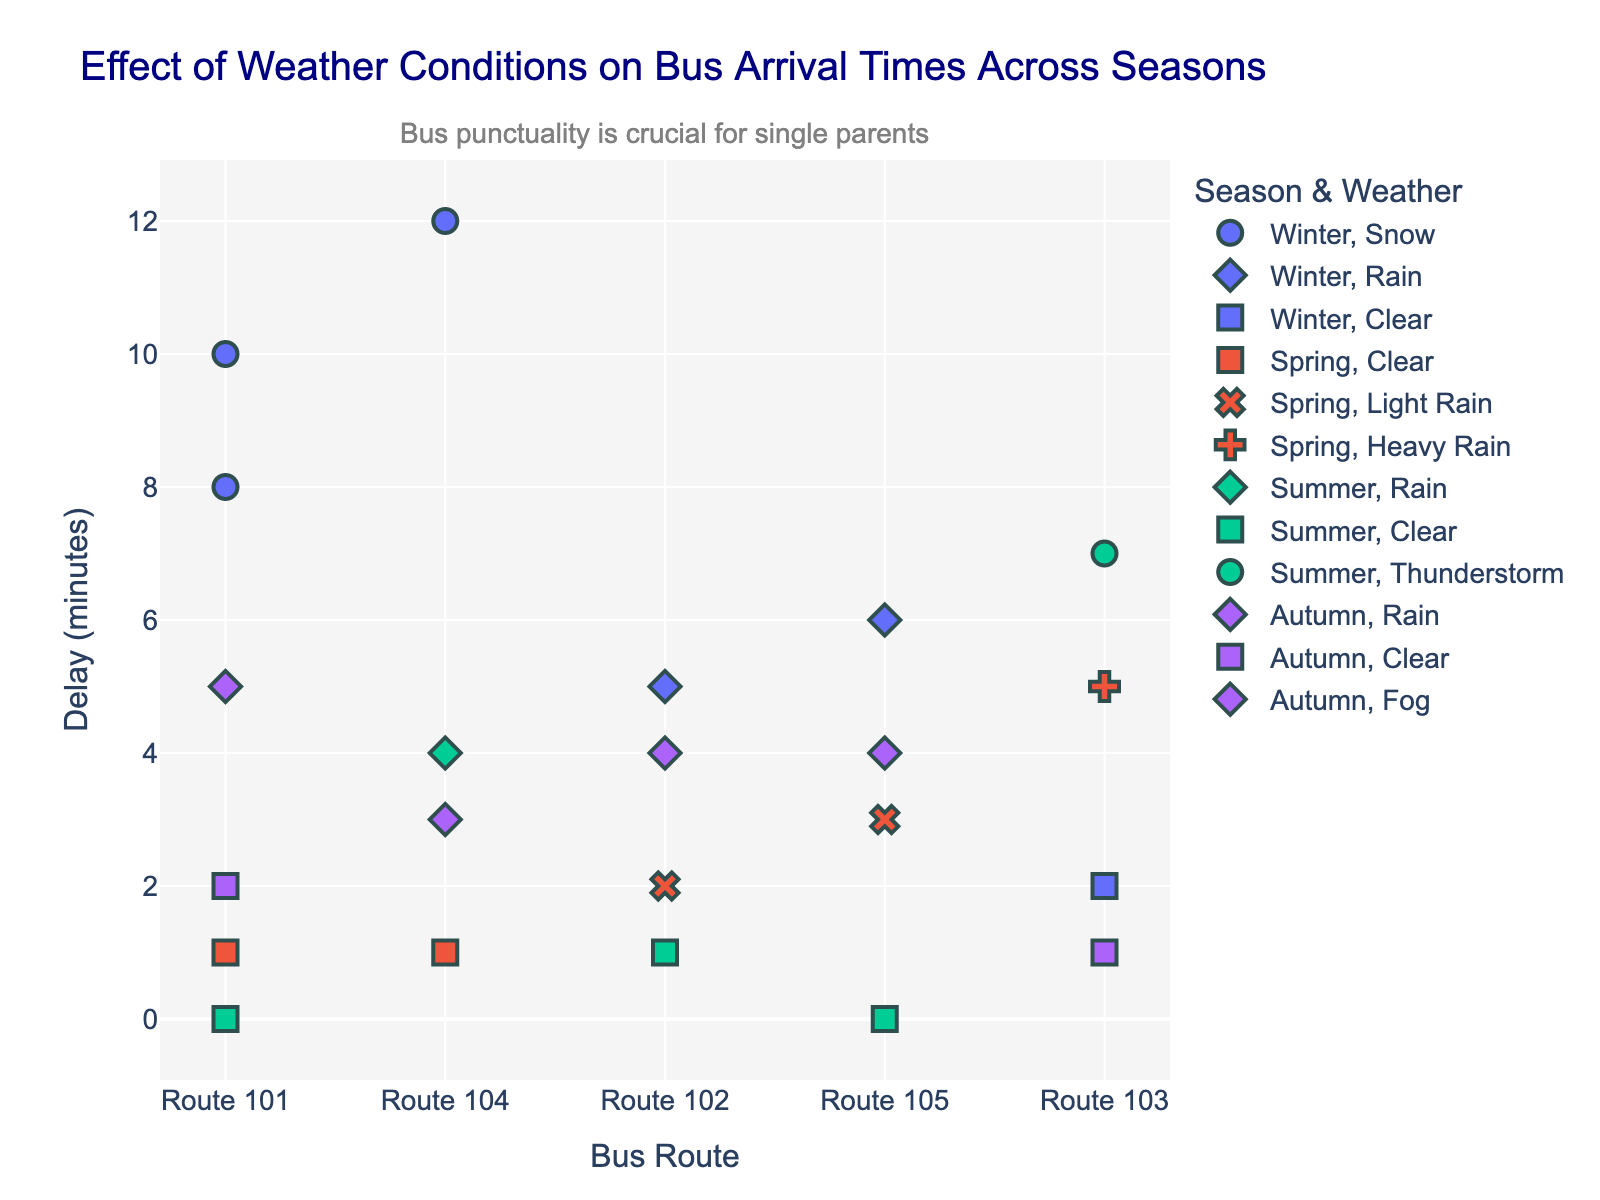What is the title of the figure? The title is usually displayed prominently at the top of the figure. By looking at this area, we can see the actual title given to the figure.
Answer: "Effect of Weather Conditions on Bus Arrival Times Across Seasons" Which season shows the longest delay time for any bus route? To find this, identify the data point with the highest y-value (representing the delay time). Then, check the color and legend to match it with the corresponding season.
Answer: Winter How does the arrival delay under clear weather conditions vary across seasons? Locate all the data points marked with the "Clear" weather condition symbol, and observe their corresponding delay times across different seasons. Compare how the delays differ for each season.
Answer: Winter: 2, Spring: 1, Summer: 0, Autumn: 1-2 Which bus route experienced the highest frequency of delays, and during which season and weather condition? Identify the route with the most data points plotted on the figure. Then, check the season and weather condition associated with the highest delay data point for this route.
Answer: Route 101, Winter, Snow What is the average arrival delay for Route 102 in winter? Locate the data points for Route 102 in winter. Sum the delay times and divide by the number of those points to find the average.
Answer: (5 + 6) / 2 = 5.5 Compare the delay times between rainy and clear weather in autumn. Identify and list the data points for rainy and clear weather in autumn. Compare the y-values (delay times) between these two sets.
Answer: Rain: 5, 4; Clear: 1, 2 Which weather condition generally leads to the least delay, and in which season is it observed? Examine all the weather conditions across the seasons and identify the condition that consistently has the lowest y-values (delays). Note the seasons in which this is observed.
Answer: Clear, Summer and Spring How does the arrival delay in summer during a thunderstorm compare to any winter delay during snow? Compare the delay time of the thunderstorm data point in summer to the delay times of all data points with snow in winter.
Answer: Summer Thunderstorm: 7, Winter Snow: 8, 10, 12 What is the range of arrival delays for Route 103 across all seasons? List the delay times for Route 103 in all seasons and find the difference between the maximum and minimum values.
Answer: Range is 7 - 1 = 6 Which season had the most varied weather conditions and how did this affect the delays? Count the different weather conditions observed in each season and analyze the associated delay times.
Answer: Winter; It had Snow, Rain, and Clear conditions causing delays ranging from 2 to 12 minutes 